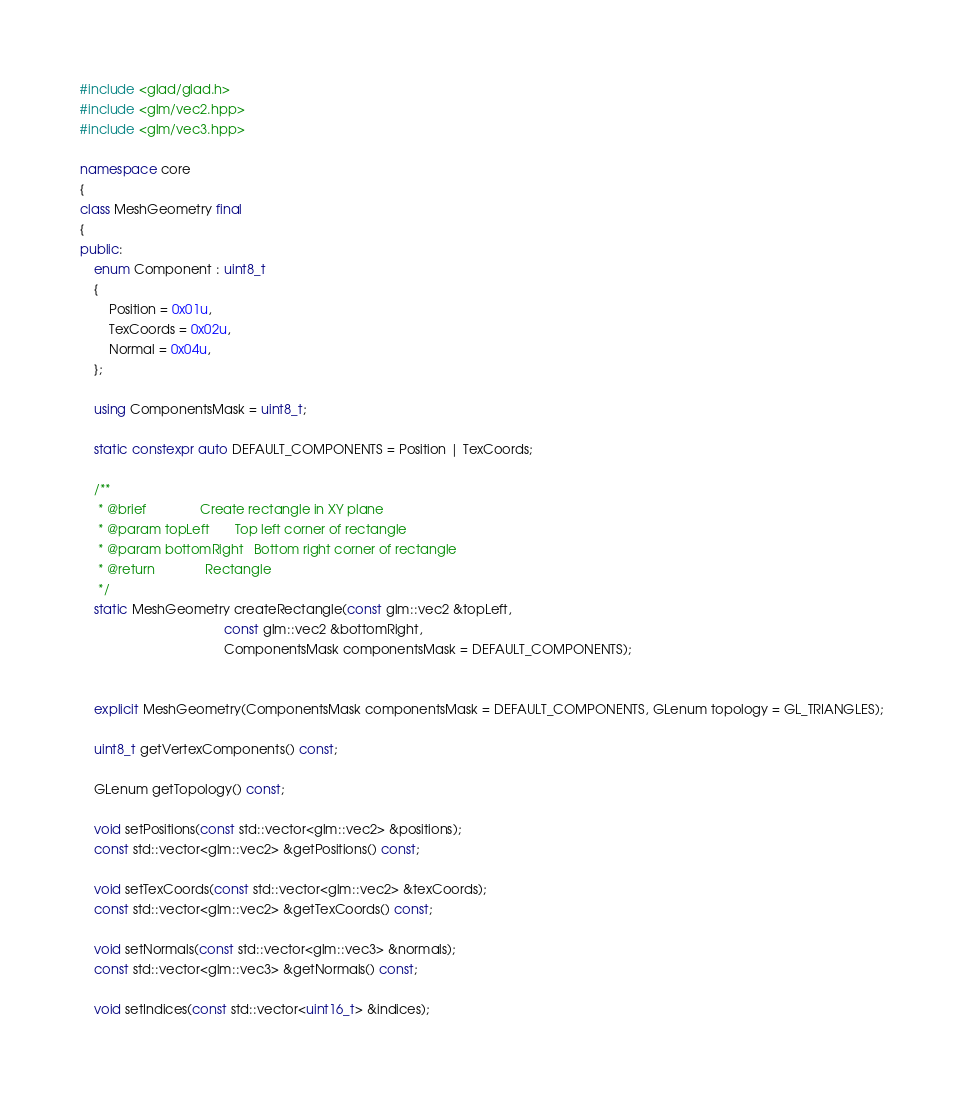Convert code to text. <code><loc_0><loc_0><loc_500><loc_500><_C++_>
#include <glad/glad.h>
#include <glm/vec2.hpp>
#include <glm/vec3.hpp>

namespace core
{
class MeshGeometry final
{
public:
    enum Component : uint8_t
    {
        Position = 0x01u,
        TexCoords = 0x02u,
        Normal = 0x04u,
    };

    using ComponentsMask = uint8_t;

    static constexpr auto DEFAULT_COMPONENTS = Position | TexCoords;

    /**
     * @brief               Create rectangle in XY plane
     * @param topLeft       Top left corner of rectangle
     * @param bottomRight   Bottom right corner of rectangle
     * @return              Rectangle
     */
    static MeshGeometry createRectangle(const glm::vec2 &topLeft,
                                        const glm::vec2 &bottomRight,
                                        ComponentsMask componentsMask = DEFAULT_COMPONENTS);


    explicit MeshGeometry(ComponentsMask componentsMask = DEFAULT_COMPONENTS, GLenum topology = GL_TRIANGLES);

    uint8_t getVertexComponents() const;

    GLenum getTopology() const;

    void setPositions(const std::vector<glm::vec2> &positions);
    const std::vector<glm::vec2> &getPositions() const;

    void setTexCoords(const std::vector<glm::vec2> &texCoords);
    const std::vector<glm::vec2> &getTexCoords() const;

    void setNormals(const std::vector<glm::vec3> &normals);
    const std::vector<glm::vec3> &getNormals() const;

    void setIndices(const std::vector<uint16_t> &indices);</code> 